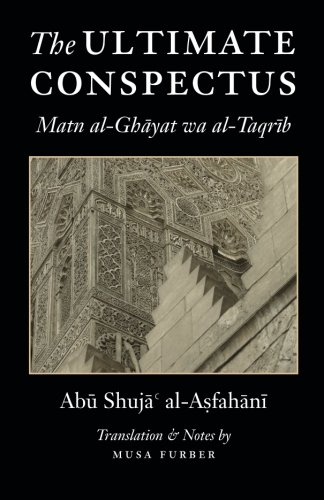How can this book benefit someone studying Islamic law? This book serves as a concise guide to Shafi'i jurisprudence, offering clear explanations and provisions which can greatly benefit students and scholars of Islamic law by providing foundational texts and interpretations. 